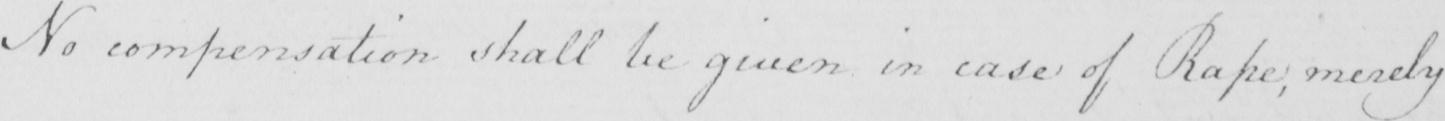Please transcribe the handwritten text in this image. No compensation shall be given in case of Rape ; merely 